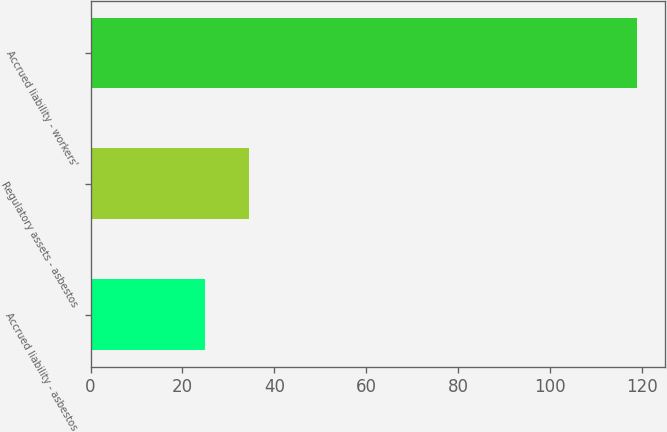Convert chart. <chart><loc_0><loc_0><loc_500><loc_500><bar_chart><fcel>Accrued liability - asbestos<fcel>Regulatory assets - asbestos<fcel>Accrued liability - workers'<nl><fcel>25<fcel>34.4<fcel>119<nl></chart> 